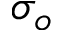<formula> <loc_0><loc_0><loc_500><loc_500>\sigma _ { o }</formula> 